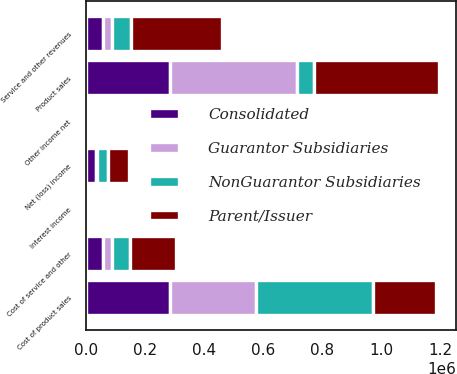<chart> <loc_0><loc_0><loc_500><loc_500><stacked_bar_chart><ecel><fcel>Product sales<fcel>Service and other revenues<fcel>Cost of product sales<fcel>Cost of service and other<fcel>Interest income<fcel>Other income net<fcel>Net (loss) income<nl><fcel>Parent/Issuer<fcel>420960<fcel>307097<fcel>211665<fcel>155555<fcel>1950<fcel>3051<fcel>73634<nl><fcel>NonGuarantor Subsidiaries<fcel>58041<fcel>63313<fcel>396747<fcel>61285<fcel>159<fcel>699<fcel>37385<nl><fcel>Guarantor Subsidiaries<fcel>431689<fcel>32555<fcel>292928<fcel>30713<fcel>840<fcel>557<fcel>2640<nl><fcel>Consolidated<fcel>284501<fcel>58041<fcel>284501<fcel>58041<fcel>609<fcel>609<fcel>34745<nl></chart> 